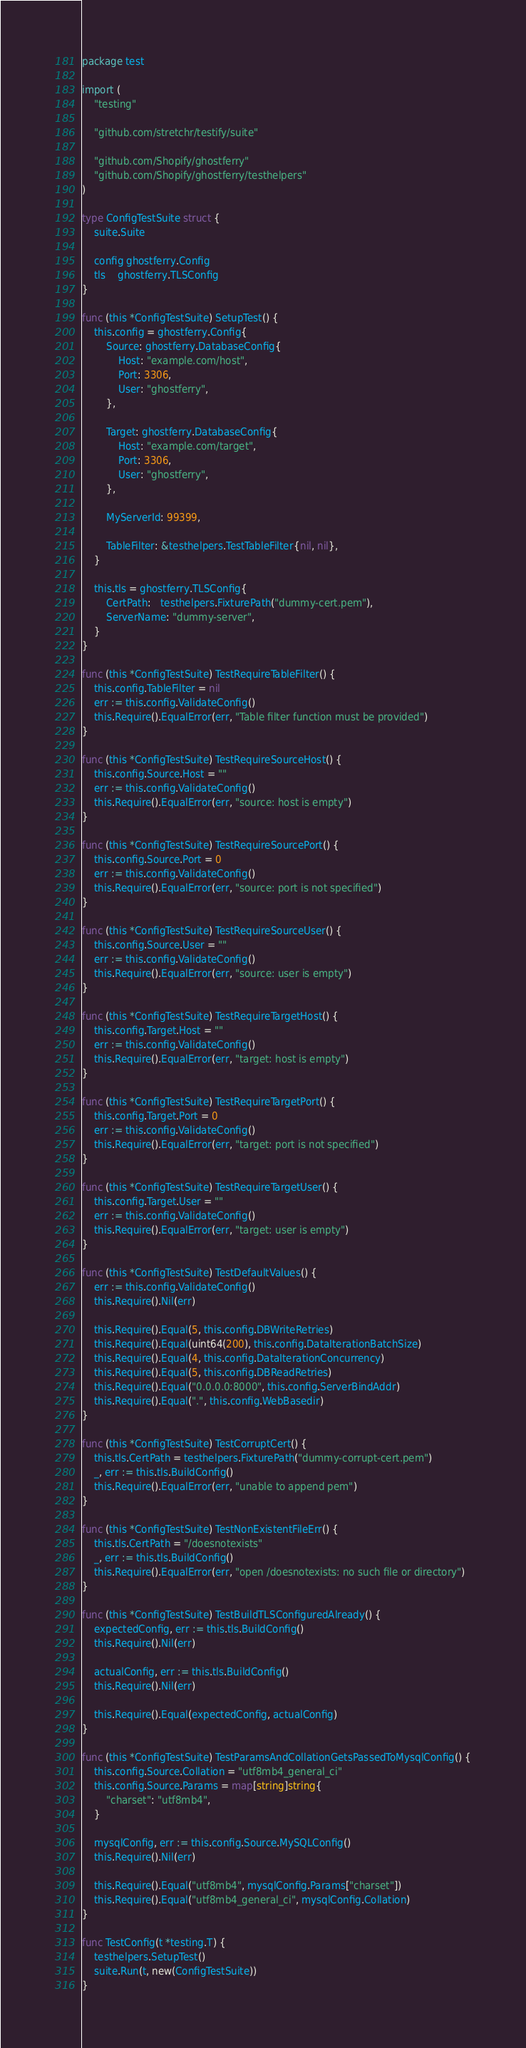Convert code to text. <code><loc_0><loc_0><loc_500><loc_500><_Go_>package test

import (
	"testing"

	"github.com/stretchr/testify/suite"

	"github.com/Shopify/ghostferry"
	"github.com/Shopify/ghostferry/testhelpers"
)

type ConfigTestSuite struct {
	suite.Suite

	config ghostferry.Config
	tls    ghostferry.TLSConfig
}

func (this *ConfigTestSuite) SetupTest() {
	this.config = ghostferry.Config{
		Source: ghostferry.DatabaseConfig{
			Host: "example.com/host",
			Port: 3306,
			User: "ghostferry",
		},

		Target: ghostferry.DatabaseConfig{
			Host: "example.com/target",
			Port: 3306,
			User: "ghostferry",
		},

		MyServerId: 99399,

		TableFilter: &testhelpers.TestTableFilter{nil, nil},
	}

	this.tls = ghostferry.TLSConfig{
		CertPath:   testhelpers.FixturePath("dummy-cert.pem"),
		ServerName: "dummy-server",
	}
}

func (this *ConfigTestSuite) TestRequireTableFilter() {
	this.config.TableFilter = nil
	err := this.config.ValidateConfig()
	this.Require().EqualError(err, "Table filter function must be provided")
}

func (this *ConfigTestSuite) TestRequireSourceHost() {
	this.config.Source.Host = ""
	err := this.config.ValidateConfig()
	this.Require().EqualError(err, "source: host is empty")
}

func (this *ConfigTestSuite) TestRequireSourcePort() {
	this.config.Source.Port = 0
	err := this.config.ValidateConfig()
	this.Require().EqualError(err, "source: port is not specified")
}

func (this *ConfigTestSuite) TestRequireSourceUser() {
	this.config.Source.User = ""
	err := this.config.ValidateConfig()
	this.Require().EqualError(err, "source: user is empty")
}

func (this *ConfigTestSuite) TestRequireTargetHost() {
	this.config.Target.Host = ""
	err := this.config.ValidateConfig()
	this.Require().EqualError(err, "target: host is empty")
}

func (this *ConfigTestSuite) TestRequireTargetPort() {
	this.config.Target.Port = 0
	err := this.config.ValidateConfig()
	this.Require().EqualError(err, "target: port is not specified")
}

func (this *ConfigTestSuite) TestRequireTargetUser() {
	this.config.Target.User = ""
	err := this.config.ValidateConfig()
	this.Require().EqualError(err, "target: user is empty")
}

func (this *ConfigTestSuite) TestDefaultValues() {
	err := this.config.ValidateConfig()
	this.Require().Nil(err)

	this.Require().Equal(5, this.config.DBWriteRetries)
	this.Require().Equal(uint64(200), this.config.DataIterationBatchSize)
	this.Require().Equal(4, this.config.DataIterationConcurrency)
	this.Require().Equal(5, this.config.DBReadRetries)
	this.Require().Equal("0.0.0.0:8000", this.config.ServerBindAddr)
	this.Require().Equal(".", this.config.WebBasedir)
}

func (this *ConfigTestSuite) TestCorruptCert() {
	this.tls.CertPath = testhelpers.FixturePath("dummy-corrupt-cert.pem")
	_, err := this.tls.BuildConfig()
	this.Require().EqualError(err, "unable to append pem")
}

func (this *ConfigTestSuite) TestNonExistentFileErr() {
	this.tls.CertPath = "/doesnotexists"
	_, err := this.tls.BuildConfig()
	this.Require().EqualError(err, "open /doesnotexists: no such file or directory")
}

func (this *ConfigTestSuite) TestBuildTLSConfiguredAlready() {
	expectedConfig, err := this.tls.BuildConfig()
	this.Require().Nil(err)

	actualConfig, err := this.tls.BuildConfig()
	this.Require().Nil(err)

	this.Require().Equal(expectedConfig, actualConfig)
}

func (this *ConfigTestSuite) TestParamsAndCollationGetsPassedToMysqlConfig() {
	this.config.Source.Collation = "utf8mb4_general_ci"
	this.config.Source.Params = map[string]string{
		"charset": "utf8mb4",
	}

	mysqlConfig, err := this.config.Source.MySQLConfig()
	this.Require().Nil(err)

	this.Require().Equal("utf8mb4", mysqlConfig.Params["charset"])
	this.Require().Equal("utf8mb4_general_ci", mysqlConfig.Collation)
}

func TestConfig(t *testing.T) {
	testhelpers.SetupTest()
	suite.Run(t, new(ConfigTestSuite))
}
</code> 